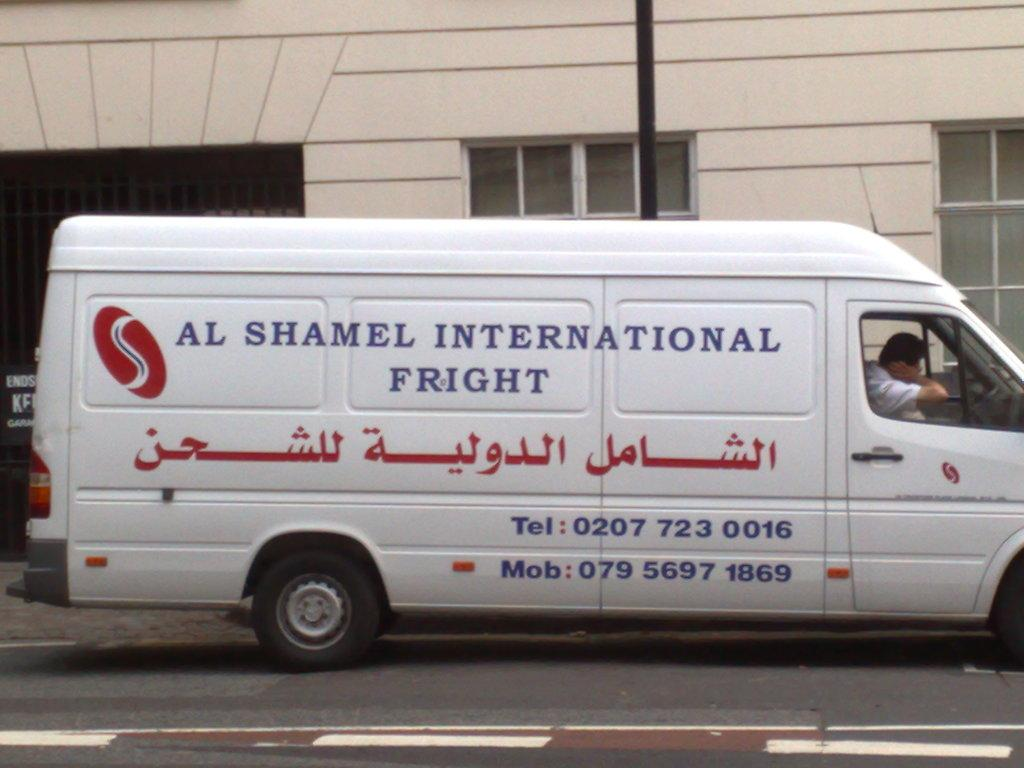Provide a one-sentence caption for the provided image. A white van with arabic text on the bottom and sal shamel international fright on the top. 